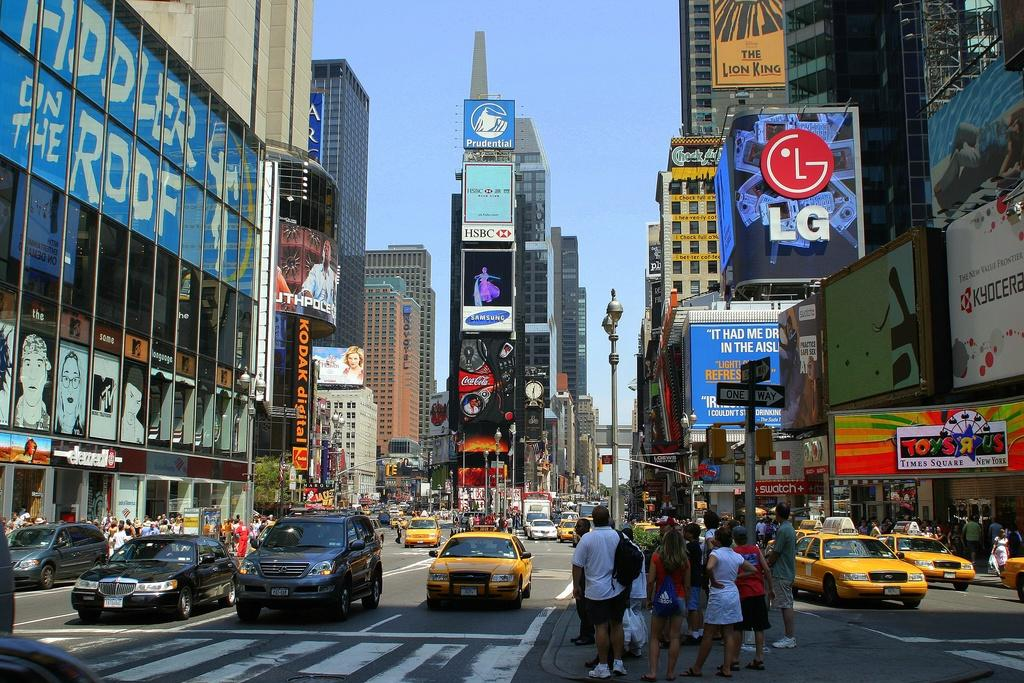<image>
Render a clear and concise summary of the photo. NYC billboards display ads for companies like LG, Coca Cola and Kyocera. 